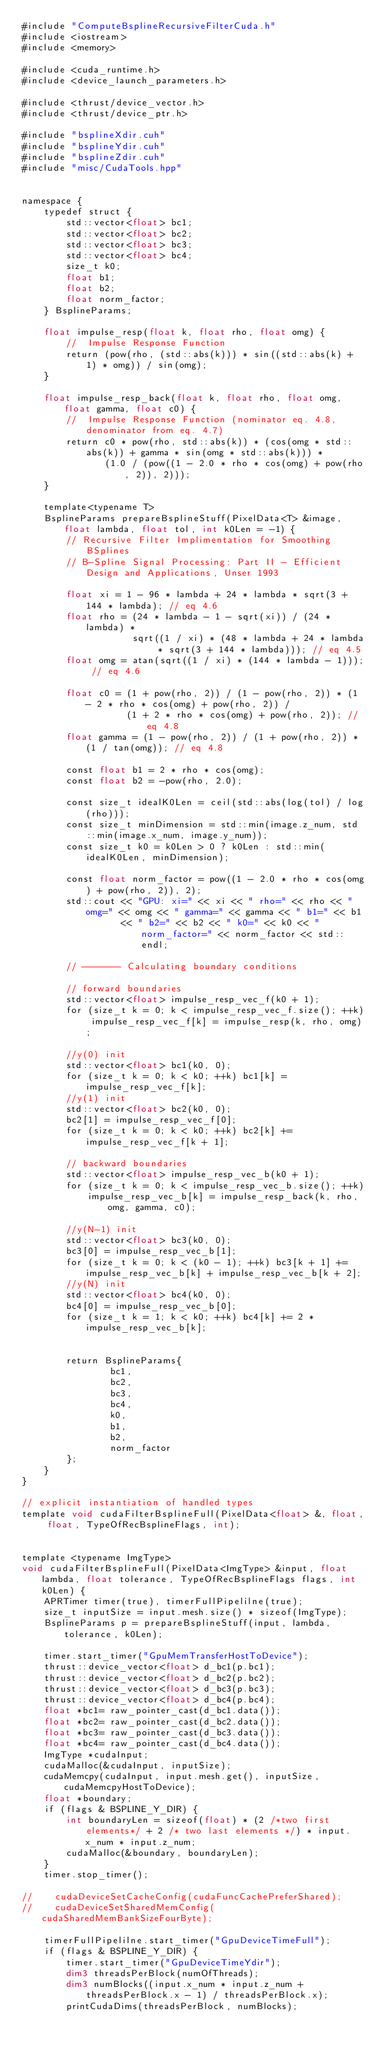Convert code to text. <code><loc_0><loc_0><loc_500><loc_500><_Cuda_>#include "ComputeBsplineRecursiveFilterCuda.h"
#include <iostream>
#include <memory>

#include <cuda_runtime.h>
#include <device_launch_parameters.h>

#include <thrust/device_vector.h>
#include <thrust/device_ptr.h>

#include "bsplineXdir.cuh"
#include "bsplineYdir.cuh"
#include "bsplineZdir.cuh"
#include "misc/CudaTools.hpp"


namespace {
    typedef struct {
        std::vector<float> bc1;
        std::vector<float> bc2;
        std::vector<float> bc3;
        std::vector<float> bc4;
        size_t k0;
        float b1;
        float b2;
        float norm_factor;
    } BsplineParams;

    float impulse_resp(float k, float rho, float omg) {
        //  Impulse Response Function
        return (pow(rho, (std::abs(k))) * sin((std::abs(k) + 1) * omg)) / sin(omg);
    }

    float impulse_resp_back(float k, float rho, float omg, float gamma, float c0) {
        //  Impulse Response Function (nominator eq. 4.8, denominator from eq. 4.7)
        return c0 * pow(rho, std::abs(k)) * (cos(omg * std::abs(k)) + gamma * sin(omg * std::abs(k))) *
               (1.0 / (pow((1 - 2.0 * rho * cos(omg) + pow(rho, 2)), 2)));
    }

    template<typename T>
    BsplineParams prepareBsplineStuff(PixelData<T> &image, float lambda, float tol, int k0Len = -1) {
        // Recursive Filter Implimentation for Smoothing BSplines
        // B-Spline Signal Processing: Part II - Efficient Design and Applications, Unser 1993

        float xi = 1 - 96 * lambda + 24 * lambda * sqrt(3 + 144 * lambda); // eq 4.6
        float rho = (24 * lambda - 1 - sqrt(xi)) / (24 * lambda) *
                    sqrt((1 / xi) * (48 * lambda + 24 * lambda * sqrt(3 + 144 * lambda))); // eq 4.5
        float omg = atan(sqrt((1 / xi) * (144 * lambda - 1))); // eq 4.6

        float c0 = (1 + pow(rho, 2)) / (1 - pow(rho, 2)) * (1 - 2 * rho * cos(omg) + pow(rho, 2)) /
                   (1 + 2 * rho * cos(omg) + pow(rho, 2)); // eq 4.8
        float gamma = (1 - pow(rho, 2)) / (1 + pow(rho, 2)) * (1 / tan(omg)); // eq 4.8

        const float b1 = 2 * rho * cos(omg);
        const float b2 = -pow(rho, 2.0);

        const size_t idealK0Len = ceil(std::abs(log(tol) / log(rho)));
        const size_t minDimension = std::min(image.z_num, std::min(image.x_num, image.y_num));
        const size_t k0 = k0Len > 0 ? k0Len : std::min(idealK0Len, minDimension);

        const float norm_factor = pow((1 - 2.0 * rho * cos(omg) + pow(rho, 2)), 2);
        std::cout << "GPU: xi=" << xi << " rho=" << rho << " omg=" << omg << " gamma=" << gamma << " b1=" << b1
                  << " b2=" << b2 << " k0=" << k0 << " norm_factor=" << norm_factor << std::endl;

        // ------- Calculating boundary conditions

        // forward boundaries
        std::vector<float> impulse_resp_vec_f(k0 + 1);
        for (size_t k = 0; k < impulse_resp_vec_f.size(); ++k) impulse_resp_vec_f[k] = impulse_resp(k, rho, omg);

        //y(0) init
        std::vector<float> bc1(k0, 0);
        for (size_t k = 0; k < k0; ++k) bc1[k] = impulse_resp_vec_f[k];
        //y(1) init
        std::vector<float> bc2(k0, 0);
        bc2[1] = impulse_resp_vec_f[0];
        for (size_t k = 0; k < k0; ++k) bc2[k] += impulse_resp_vec_f[k + 1];

        // backward boundaries
        std::vector<float> impulse_resp_vec_b(k0 + 1);
        for (size_t k = 0; k < impulse_resp_vec_b.size(); ++k)
            impulse_resp_vec_b[k] = impulse_resp_back(k, rho, omg, gamma, c0);

        //y(N-1) init
        std::vector<float> bc3(k0, 0);
        bc3[0] = impulse_resp_vec_b[1];
        for (size_t k = 0; k < (k0 - 1); ++k) bc3[k + 1] += impulse_resp_vec_b[k] + impulse_resp_vec_b[k + 2];
        //y(N) init
        std::vector<float> bc4(k0, 0);
        bc4[0] = impulse_resp_vec_b[0];
        for (size_t k = 1; k < k0; ++k) bc4[k] += 2 * impulse_resp_vec_b[k];


        return BsplineParams{
                bc1,
                bc2,
                bc3,
                bc4,
                k0,
                b1,
                b2,
                norm_factor
        };
    }
}

// explicit instantiation of handled types
template void cudaFilterBsplineFull(PixelData<float> &, float, float, TypeOfRecBsplineFlags, int);


template <typename ImgType>
void cudaFilterBsplineFull(PixelData<ImgType> &input, float lambda, float tolerance, TypeOfRecBsplineFlags flags, int k0Len) {
    APRTimer timer(true), timerFullPipelilne(true);
    size_t inputSize = input.mesh.size() * sizeof(ImgType);
    BsplineParams p = prepareBsplineStuff(input, lambda, tolerance, k0Len);

    timer.start_timer("GpuMemTransferHostToDevice");
    thrust::device_vector<float> d_bc1(p.bc1);
    thrust::device_vector<float> d_bc2(p.bc2);
    thrust::device_vector<float> d_bc3(p.bc3);
    thrust::device_vector<float> d_bc4(p.bc4);
    float *bc1= raw_pointer_cast(d_bc1.data());
    float *bc2= raw_pointer_cast(d_bc2.data());
    float *bc3= raw_pointer_cast(d_bc3.data());
    float *bc4= raw_pointer_cast(d_bc4.data());
    ImgType *cudaInput;
    cudaMalloc(&cudaInput, inputSize);
    cudaMemcpy(cudaInput, input.mesh.get(), inputSize, cudaMemcpyHostToDevice);
    float *boundary;
    if (flags & BSPLINE_Y_DIR) {
        int boundaryLen = sizeof(float) * (2 /*two first elements*/ + 2 /* two last elements */) * input.x_num * input.z_num;
        cudaMalloc(&boundary, boundaryLen);
    }
    timer.stop_timer();

//    cudaDeviceSetCacheConfig(cudaFuncCachePreferShared);
//    cudaDeviceSetSharedMemConfig(cudaSharedMemBankSizeFourByte);

    timerFullPipelilne.start_timer("GpuDeviceTimeFull");
    if (flags & BSPLINE_Y_DIR) {
        timer.start_timer("GpuDeviceTimeYdir");
        dim3 threadsPerBlock(numOfThreads);
        dim3 numBlocks((input.x_num * input.z_num + threadsPerBlock.x - 1) / threadsPerBlock.x);
        printCudaDims(threadsPerBlock, numBlocks);</code> 